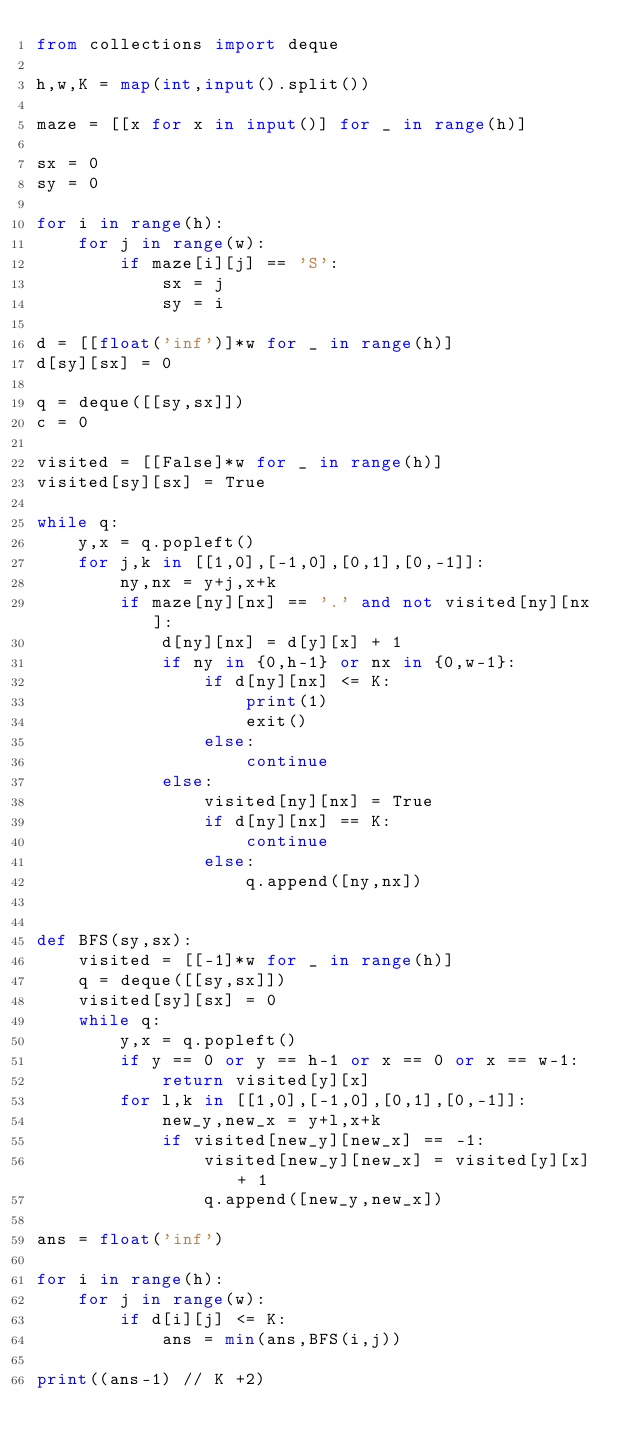Convert code to text. <code><loc_0><loc_0><loc_500><loc_500><_Python_>from collections import deque

h,w,K = map(int,input().split())

maze = [[x for x in input()] for _ in range(h)]

sx = 0
sy = 0

for i in range(h):
    for j in range(w):
        if maze[i][j] == 'S':
            sx = j
            sy = i

d = [[float('inf')]*w for _ in range(h)]
d[sy][sx] = 0

q = deque([[sy,sx]])
c = 0

visited = [[False]*w for _ in range(h)]
visited[sy][sx] = True

while q:
    y,x = q.popleft()
    for j,k in [[1,0],[-1,0],[0,1],[0,-1]]:
        ny,nx = y+j,x+k
        if maze[ny][nx] == '.' and not visited[ny][nx]:
            d[ny][nx] = d[y][x] + 1
            if ny in {0,h-1} or nx in {0,w-1}:
                if d[ny][nx] <= K:
                    print(1)
                    exit()
                else:
                    continue
            else:
                visited[ny][nx] = True
                if d[ny][nx] == K:
                    continue
                else:
                    q.append([ny,nx])
    

def BFS(sy,sx):
    visited = [[-1]*w for _ in range(h)]
    q = deque([[sy,sx]])
    visited[sy][sx] = 0
    while q:
        y,x = q.popleft()
        if y == 0 or y == h-1 or x == 0 or x == w-1:
            return visited[y][x]
        for l,k in [[1,0],[-1,0],[0,1],[0,-1]]:
            new_y,new_x = y+l,x+k
            if visited[new_y][new_x] == -1:
                visited[new_y][new_x] = visited[y][x] + 1
                q.append([new_y,new_x])

ans = float('inf')

for i in range(h):
    for j in range(w):
        if d[i][j] <= K:
            ans = min(ans,BFS(i,j))

print((ans-1) // K +2)</code> 